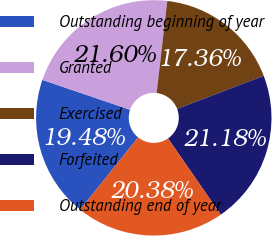<chart> <loc_0><loc_0><loc_500><loc_500><pie_chart><fcel>Outstanding beginning of year<fcel>Granted<fcel>Exercised<fcel>Forfeited<fcel>Outstanding end of year<nl><fcel>19.48%<fcel>21.6%<fcel>17.36%<fcel>21.18%<fcel>20.38%<nl></chart> 